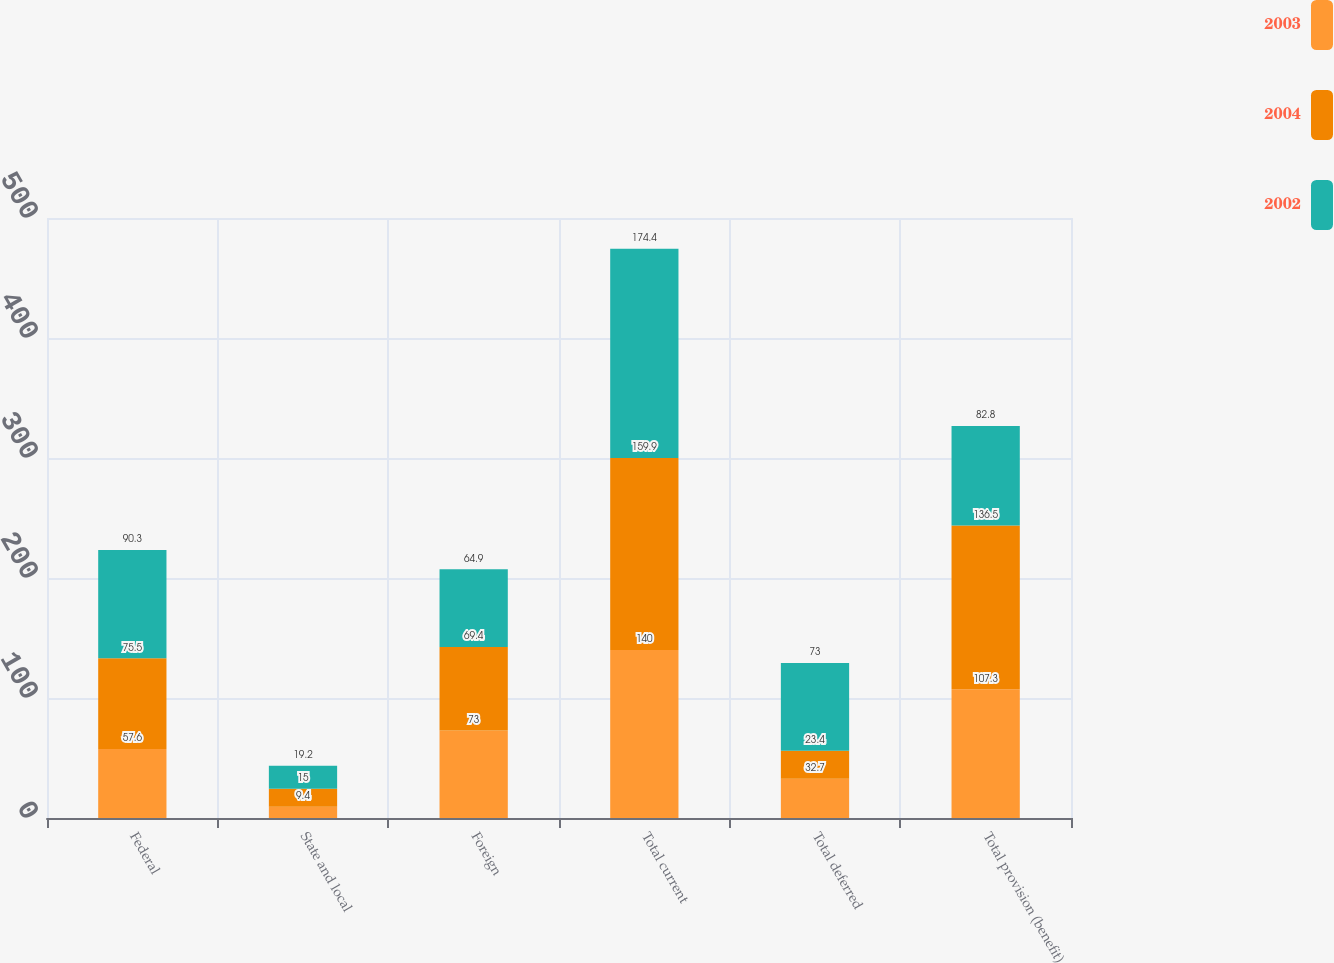Convert chart to OTSL. <chart><loc_0><loc_0><loc_500><loc_500><stacked_bar_chart><ecel><fcel>Federal<fcel>State and local<fcel>Foreign<fcel>Total current<fcel>Total deferred<fcel>Total provision (benefit)<nl><fcel>2003<fcel>57.6<fcel>9.4<fcel>73<fcel>140<fcel>32.7<fcel>107.3<nl><fcel>2004<fcel>75.5<fcel>15<fcel>69.4<fcel>159.9<fcel>23.4<fcel>136.5<nl><fcel>2002<fcel>90.3<fcel>19.2<fcel>64.9<fcel>174.4<fcel>73<fcel>82.8<nl></chart> 